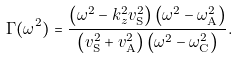<formula> <loc_0><loc_0><loc_500><loc_500>\Gamma ( \omega ^ { 2 } ) = \frac { \left ( \omega ^ { 2 } - k _ { z } ^ { 2 } v _ { \mathrm S } ^ { 2 } \right ) \left ( \omega ^ { 2 } - \omega _ { \mathrm A } ^ { 2 } \right ) } { \left ( v _ { \mathrm S } ^ { 2 } + v _ { \mathrm A } ^ { 2 } \right ) \left ( \omega ^ { 2 } - \omega _ { \mathrm C } ^ { 2 } \right ) } .</formula> 